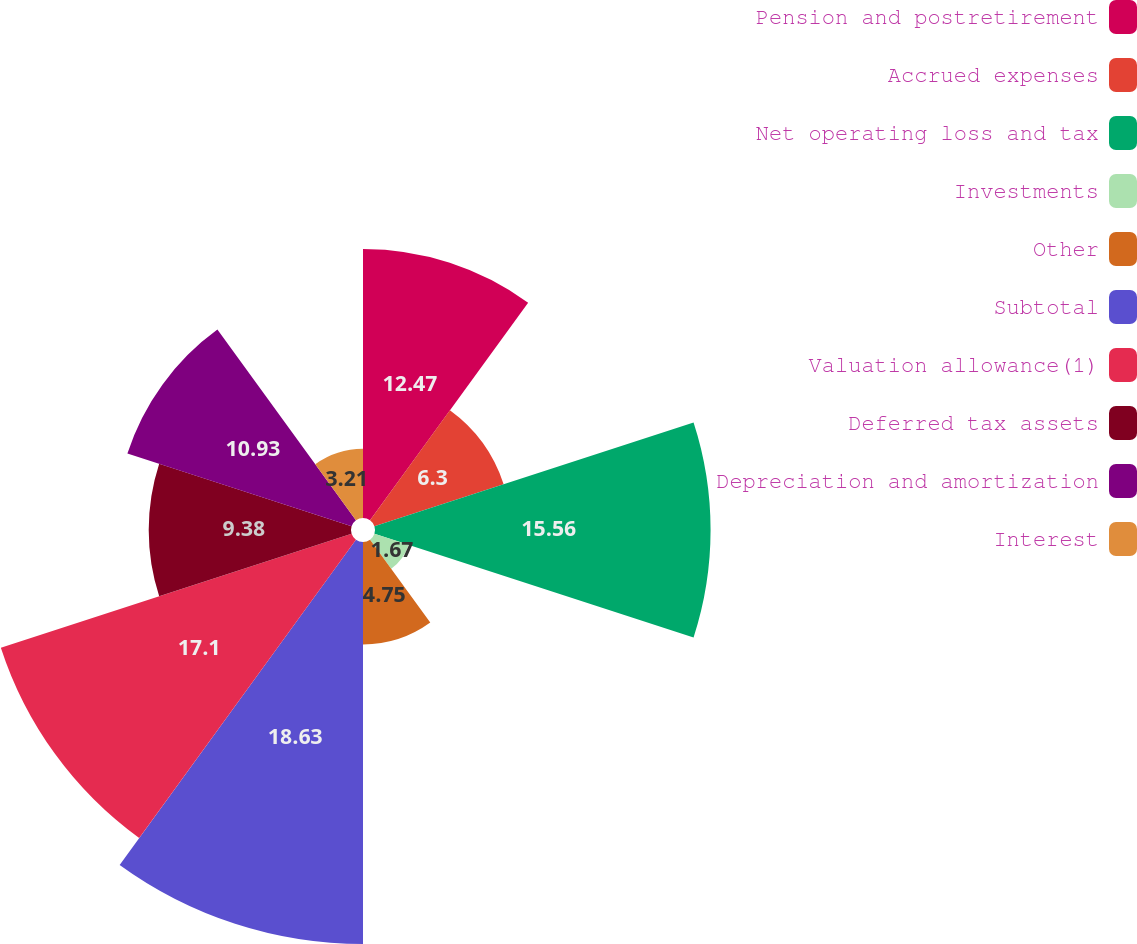Convert chart to OTSL. <chart><loc_0><loc_0><loc_500><loc_500><pie_chart><fcel>Pension and postretirement<fcel>Accrued expenses<fcel>Net operating loss and tax<fcel>Investments<fcel>Other<fcel>Subtotal<fcel>Valuation allowance(1)<fcel>Deferred tax assets<fcel>Depreciation and amortization<fcel>Interest<nl><fcel>12.47%<fcel>6.3%<fcel>15.56%<fcel>1.67%<fcel>4.75%<fcel>18.64%<fcel>17.1%<fcel>9.38%<fcel>10.93%<fcel>3.21%<nl></chart> 